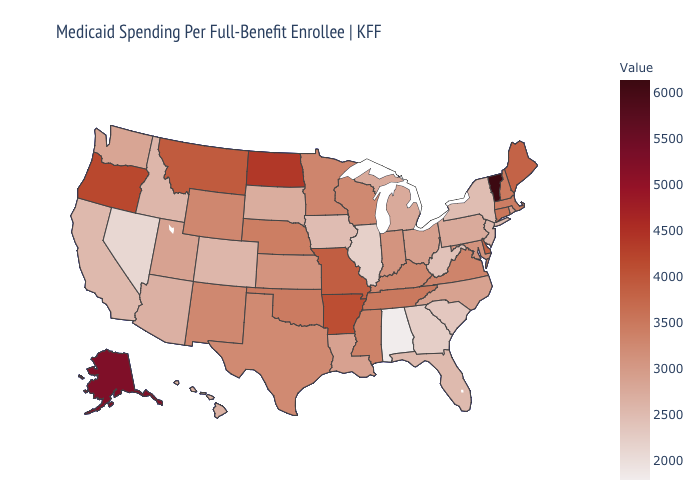Which states have the lowest value in the USA?
Quick response, please. Alabama. Does Vermont have the highest value in the USA?
Answer briefly. Yes. Does the map have missing data?
Concise answer only. No. Does New York have a lower value than Kentucky?
Give a very brief answer. Yes. Among the states that border Nevada , does Idaho have the lowest value?
Short answer required. No. Does Kentucky have a lower value than North Dakota?
Write a very short answer. Yes. Does Massachusetts have a lower value than Montana?
Give a very brief answer. Yes. 